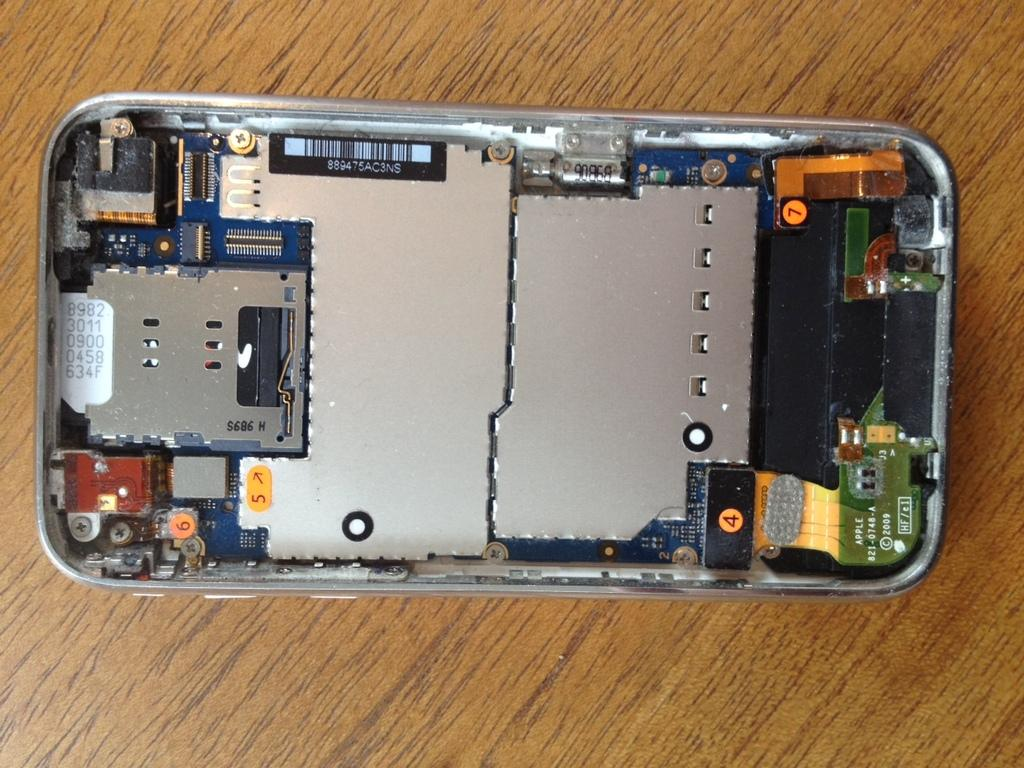<image>
Relay a brief, clear account of the picture shown. The back of an Apple phone with date 2009 and the number 4. 